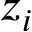<formula> <loc_0><loc_0><loc_500><loc_500>z _ { i }</formula> 